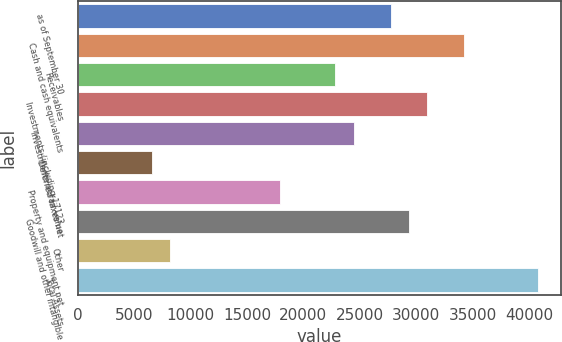Convert chart to OTSL. <chart><loc_0><loc_0><loc_500><loc_500><bar_chart><fcel>as of September 30<fcel>Cash and cash equivalents<fcel>Receivables<fcel>Investments (including 17123<fcel>Investments at fair value<fcel>Deferred taxes net<fcel>Property and equipment net<fcel>Goodwill and other intangible<fcel>Other<fcel>Total Assets<nl><fcel>27729<fcel>34239.4<fcel>22846.1<fcel>30984.2<fcel>24473.8<fcel>6570.04<fcel>17963.3<fcel>29356.6<fcel>8197.65<fcel>40749.8<nl></chart> 